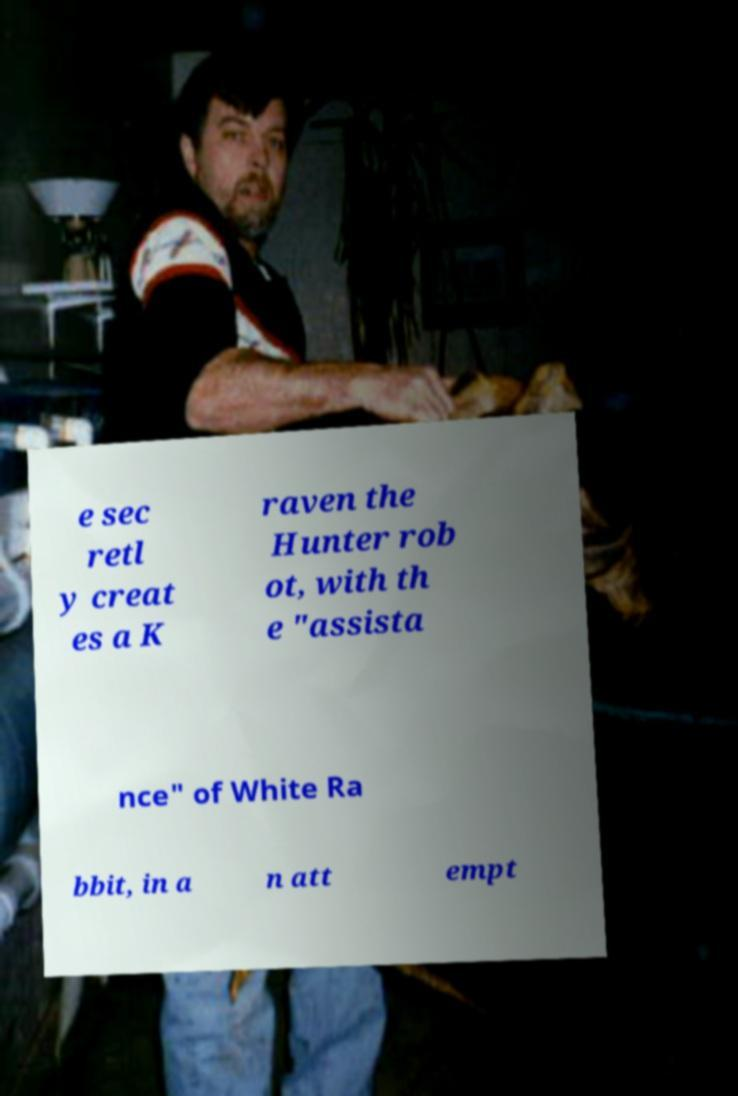I need the written content from this picture converted into text. Can you do that? e sec retl y creat es a K raven the Hunter rob ot, with th e "assista nce" of White Ra bbit, in a n att empt 